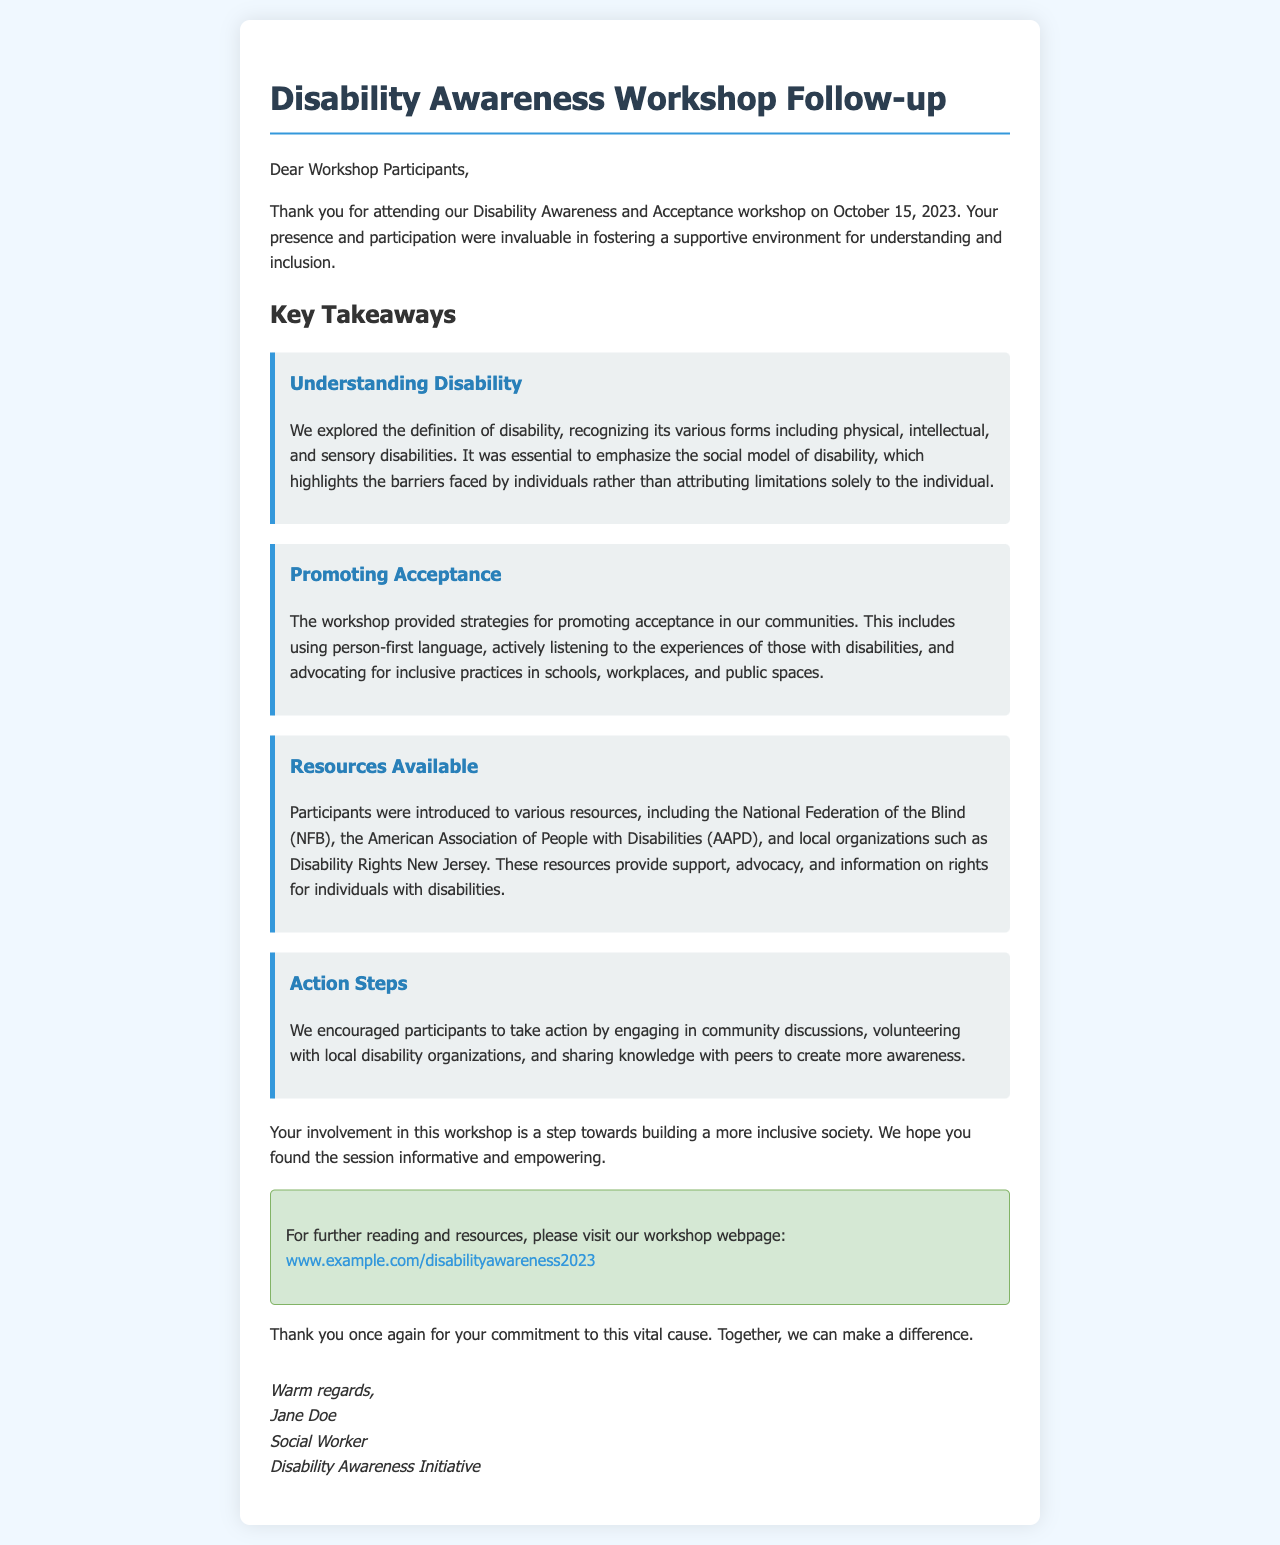What date was the workshop held? The document states the workshop was conducted on October 15, 2023.
Answer: October 15, 2023 Who authored the follow-up letter? The letter is signed by Jane Doe at the end of the document.
Answer: Jane Doe What is one of the organizations mentioned as a resource? The letter lists the National Federation of the Blind as one of the resources shared during the workshop.
Answer: National Federation of the Blind What type of language was encouraged to promote acceptance? The document emphasizes the use of person-first language in promoting acceptance.
Answer: Person-first language What is one action step suggested for participants? The workshop encouraged participants to engage in community discussions as an action step.
Answer: Engage in community discussions How many key takeaway topics are mentioned in the letter? The letter lists four distinct takeaway topics from the workshop, such as Understanding Disability, Promoting Acceptance, Resources Available, and Action Steps.
Answer: Four What color scheme is used in the letter's background? The background color of the letter container is white, and the body background is a light blue.
Answer: Light blue What is the main goal of the workshop? The document mentions that the workshop's goal is to foster understanding and inclusion within the community.
Answer: Understanding and inclusion 